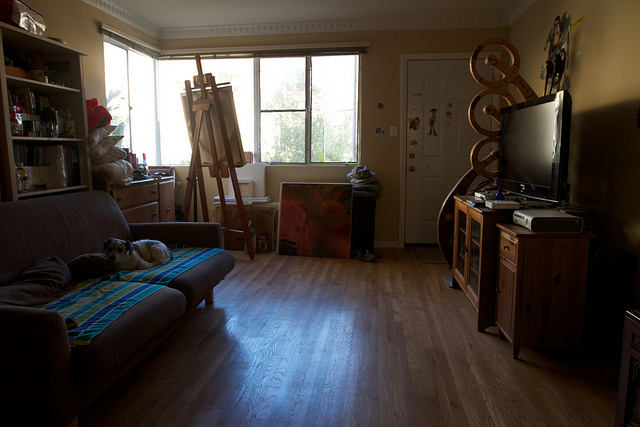Describe the mood or atmosphere in this room. The room has a cozy and creative atmosphere. The warm lighting and the presence of a painting and easel suggest that someone enjoys art here. The comfort of the sofa and the neatly arranged items create a lived-in, personal feel. 